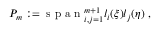Convert formula to latex. <formula><loc_0><loc_0><loc_500><loc_500>P _ { m } \colon = s p a n _ { i , j = 1 } ^ { m + 1 } l _ { i } ( \xi ) l _ { j } ( \eta ) ,</formula> 